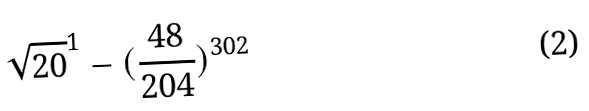<formula> <loc_0><loc_0><loc_500><loc_500>\sqrt { 2 0 } ^ { 1 } - ( \frac { 4 8 } { 2 0 4 } ) ^ { 3 0 2 }</formula> 